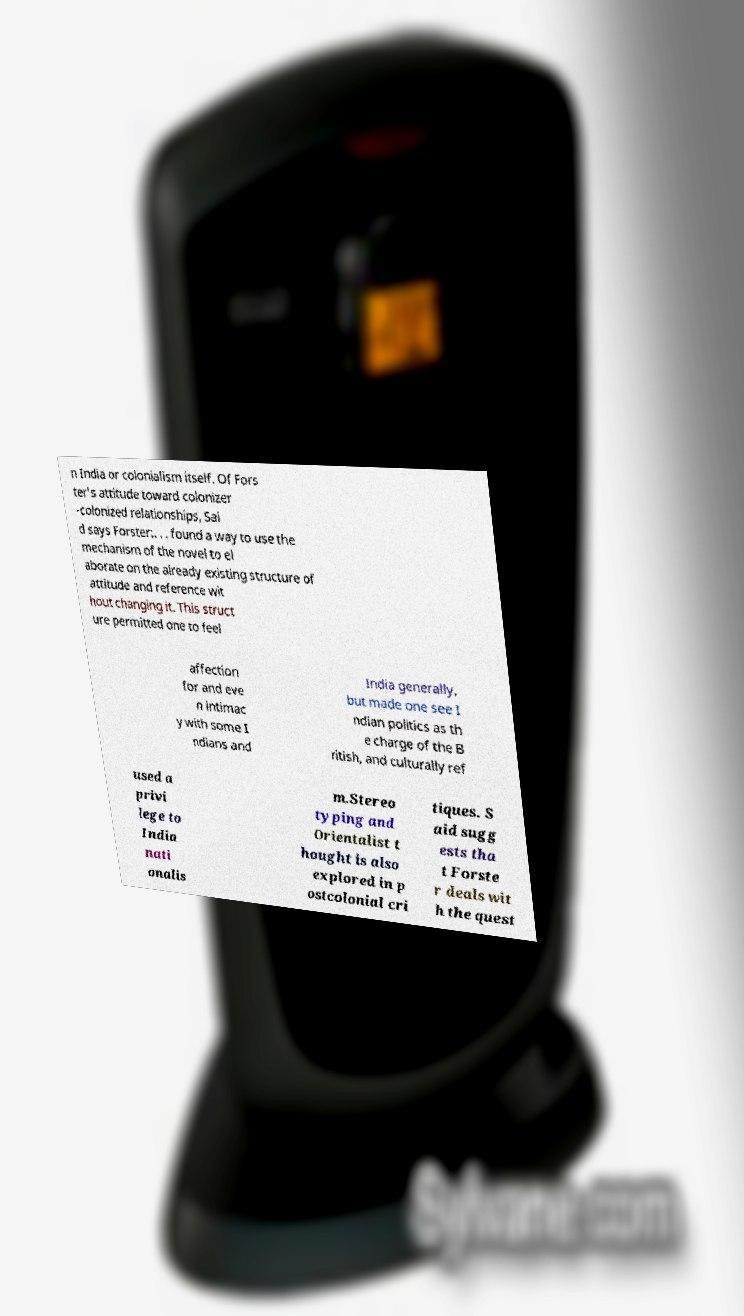What messages or text are displayed in this image? I need them in a readable, typed format. n India or colonialism itself. Of Fors ter's attitude toward colonizer -colonized relationships, Sai d says Forster:. . . found a way to use the mechanism of the novel to el aborate on the already existing structure of attitude and reference wit hout changing it. This struct ure permitted one to feel affection for and eve n intimac y with some I ndians and India generally, but made one see I ndian politics as th e charge of the B ritish, and culturally ref used a privi lege to India nati onalis m.Stereo typing and Orientalist t hought is also explored in p ostcolonial cri tiques. S aid sugg ests tha t Forste r deals wit h the quest 